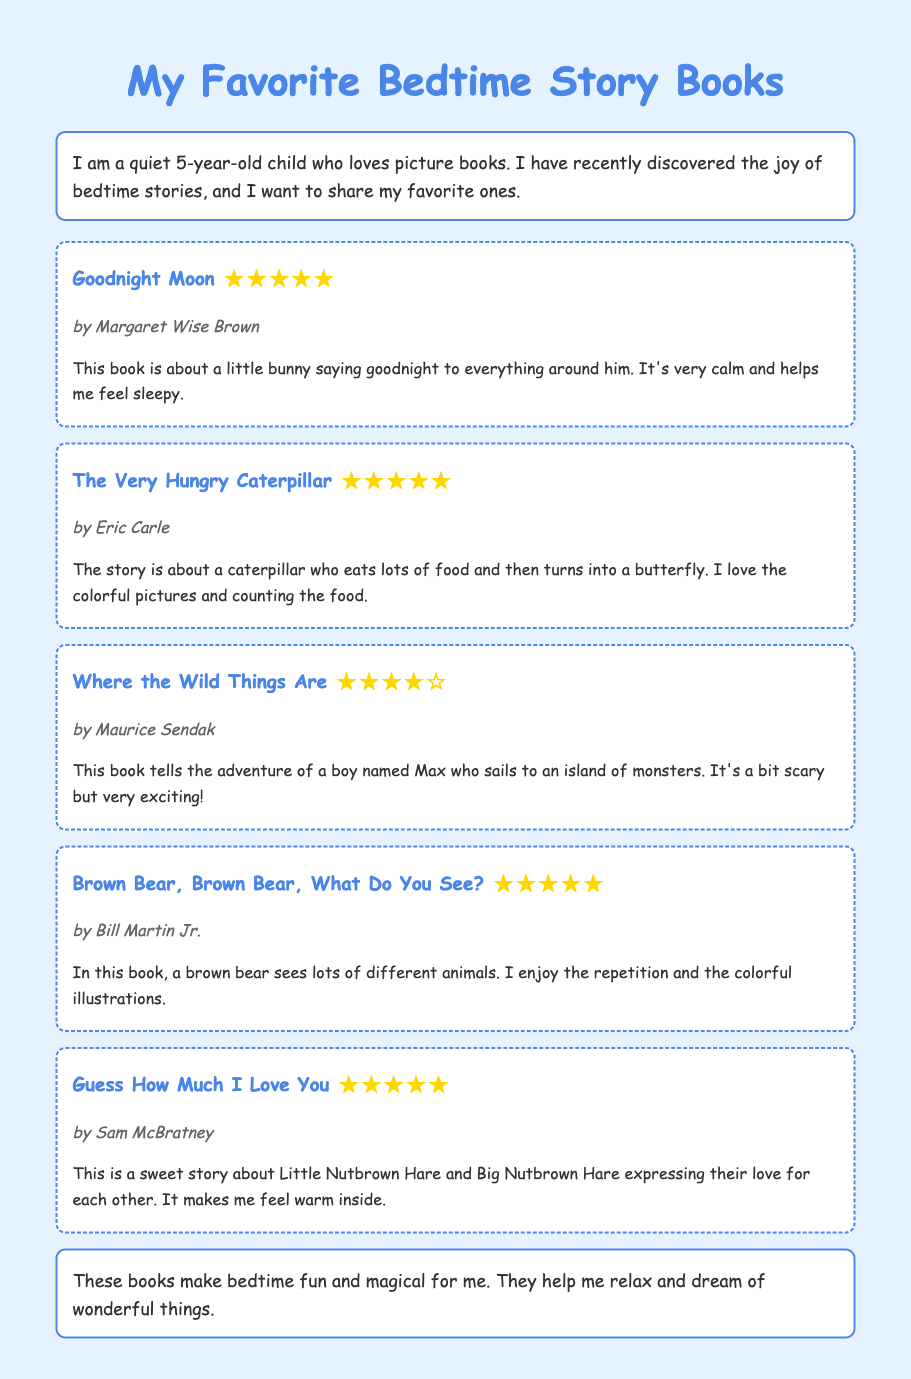What is the title of the first book? The first book listed in the document is "Goodnight Moon."
Answer: Goodnight Moon Who is the author of "The Very Hungry Caterpillar"? The author of "The Very Hungry Caterpillar" is Eric Carle.
Answer: Eric Carle How many stars does "Where the Wild Things Are" have? "Where the Wild Things Are" is rated four stars, as indicated by the rating in the document.
Answer: ★★★★☆ What is the main theme of "Guess How Much I Love You"? The main theme of "Guess How Much I Love You" is the expression of love between Little Nutbrown Hare and Big Nutbrown Hare.
Answer: Love Which book has colorful illustrations about animals? "Brown Bear, Brown Bear, What Do You See?" features colorful illustrations about animals.
Answer: Brown Bear, Brown Bear, What Do You See? How does the child feel after reading the favorite books? The child feels that these books make bedtime fun and magical.
Answer: Fun and magical What is the name of the boy in "Where the Wild Things Are"? The boy's name in "Where the Wild Things Are" is Max.
Answer: Max What do the stories help the child to do at bedtime? The stories help the child to relax and dream of wonderful things.
Answer: Relax and dream 